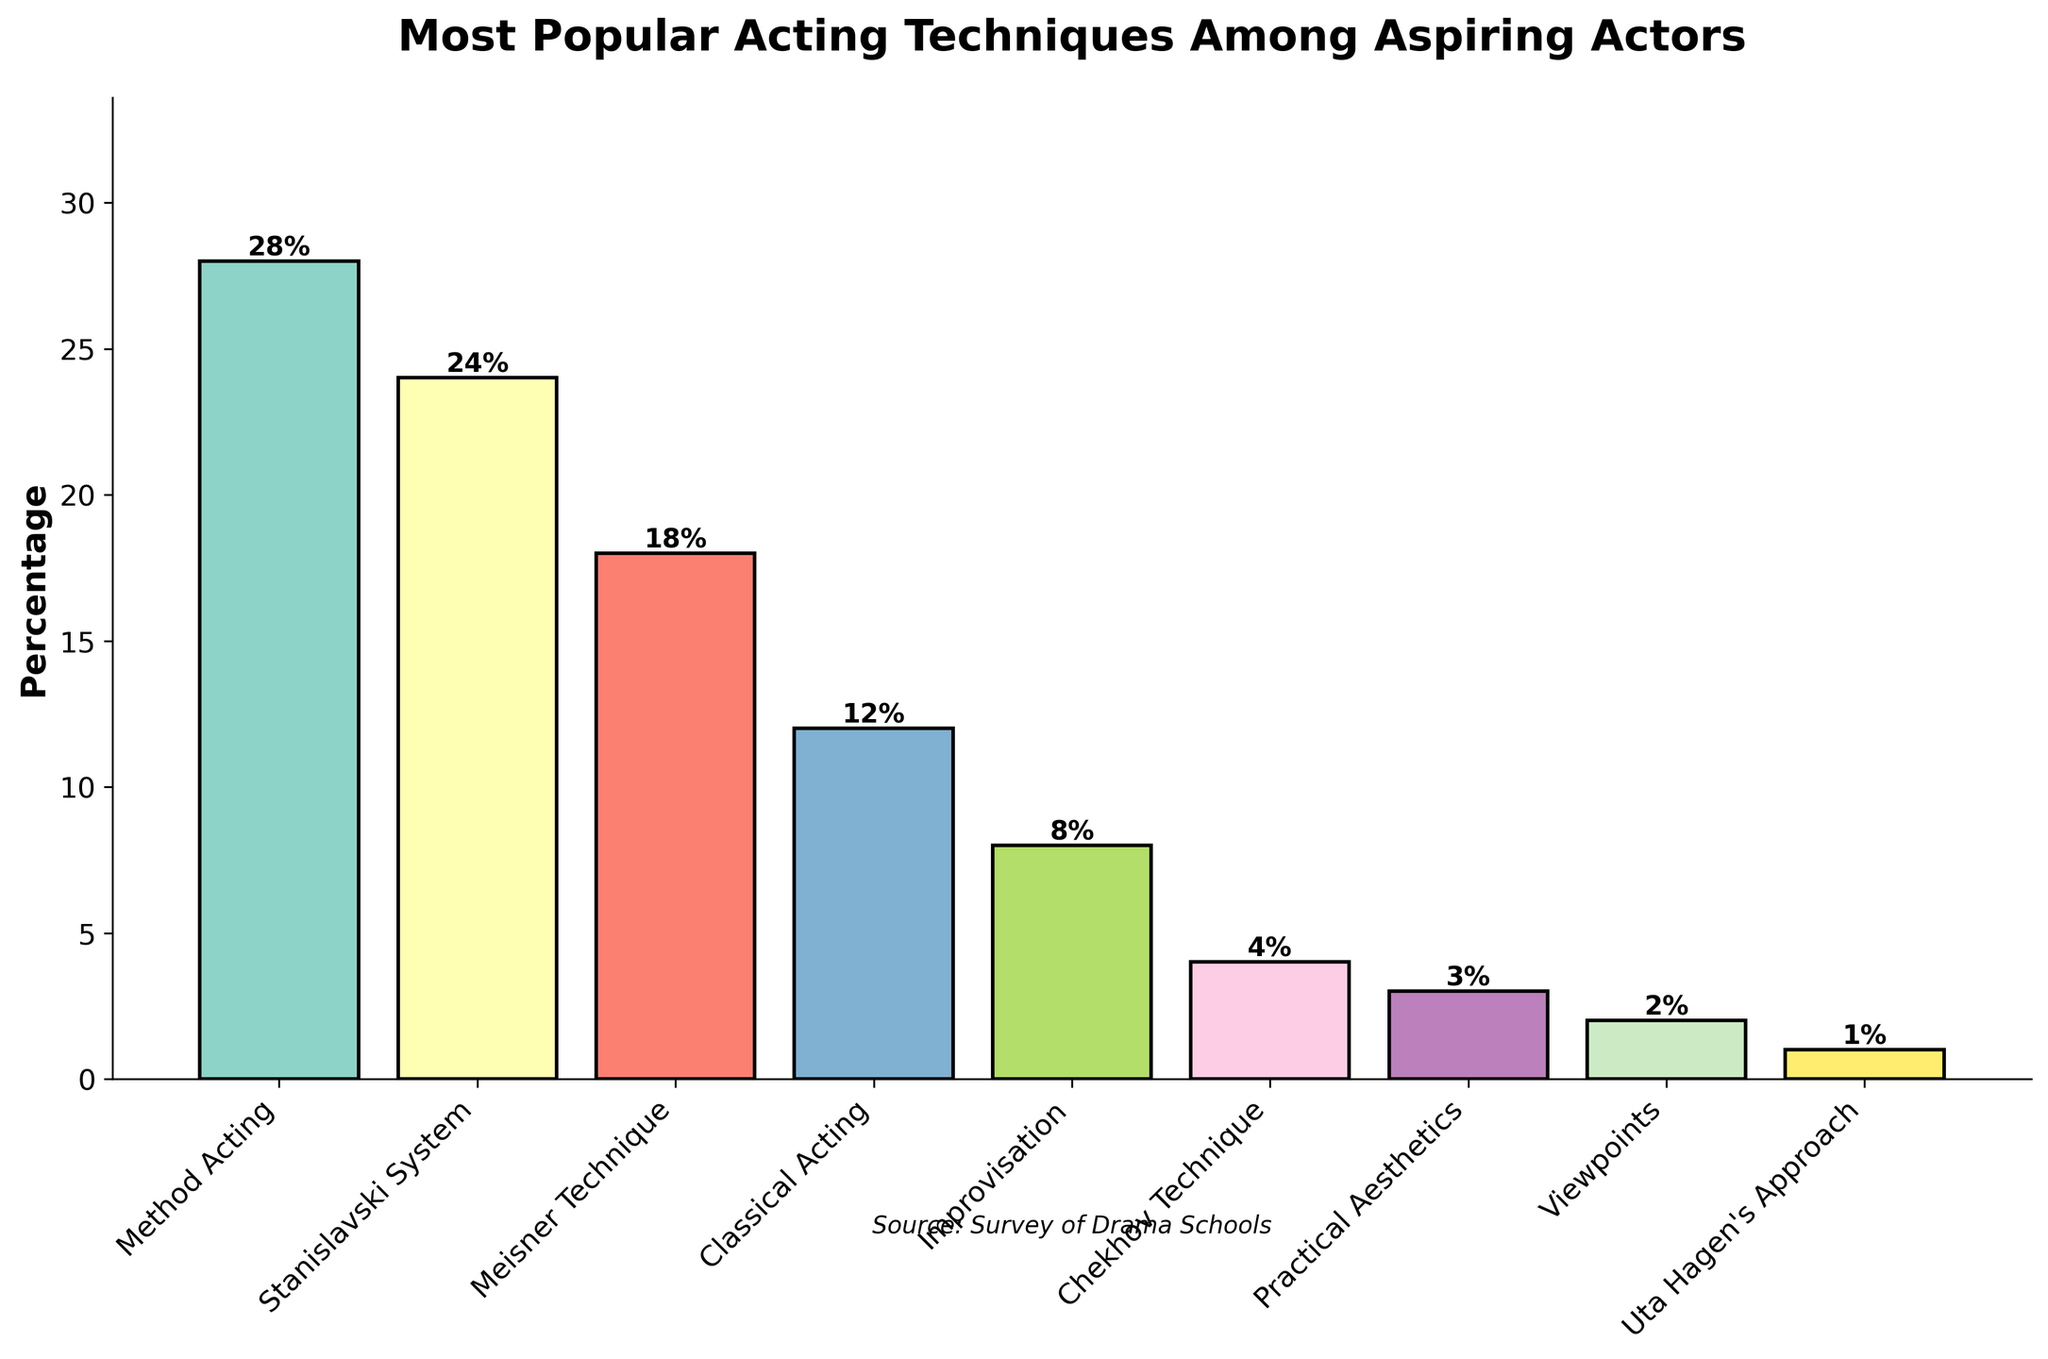Which acting technique is the most popular among aspiring actors? The Method Acting technique has the highest bar at 28%, indicating it is the most popular.
Answer: Method Acting Which two acting techniques have the closest popularity percentages? The Stanislavski System and the Meisner Technique have percentages of 24% and 18%, respectively. The difference between them is 6 percentage points, making them the closest in comparison.
Answer: Stanislavski System and Meisner Technique What is the combined percentage of actors who prefer Method Acting and Stanislavski System? The percentage for Method Acting is 28%, and for the Stanislavski System, it is 24%. Adding them together yields 28 + 24 = 52%.
Answer: 52% By what percentage is Improvisation more popular than Practical Aesthetics? Improvisation has a percentage of 8%, and Practical Aesthetics has 3%. The difference is 8 - 3 = 5%.
Answer: 5% Which acting technique is the least popular among aspiring actors? The Uta Hagen's Approach, with the smallest bar at 1%, is the least popular technique.
Answer: Uta Hagen's Approach Which techniques have a lower percentage than Meisner Technique? The Meisner Technique has a percentage of 18%. Techniques with lower percentages are Classical Acting (12%), Improvisation (8%), Chekhov Technique (4%), Practical Aesthetics (3%), Viewpoints (2%), and Uta Hagen's Approach (1%).
Answer: Classical Acting, Improvisation, Chekhov Technique, Practical Aesthetics, Viewpoints, Uta Hagen's Approach How many techniques have a percentage higher than or equal to 10%? The techniques with percentages of 10% or more are Method Acting (28%), Stanislavski System (24%), Meisner Technique (18%), Classical Acting (12%). Counting these, there are 4 techniques.
Answer: 4 If you combine the percentages for Practical Aesthetics and Viewpoints, how do they compare to Chekhov Technique? The percentage for Practical Aesthetics is 3% and for Viewpoints is 2%. Adding them gives 3 + 2 = 5%, which is higher than the Chekhov Technique at 4%.
Answer: Higher 